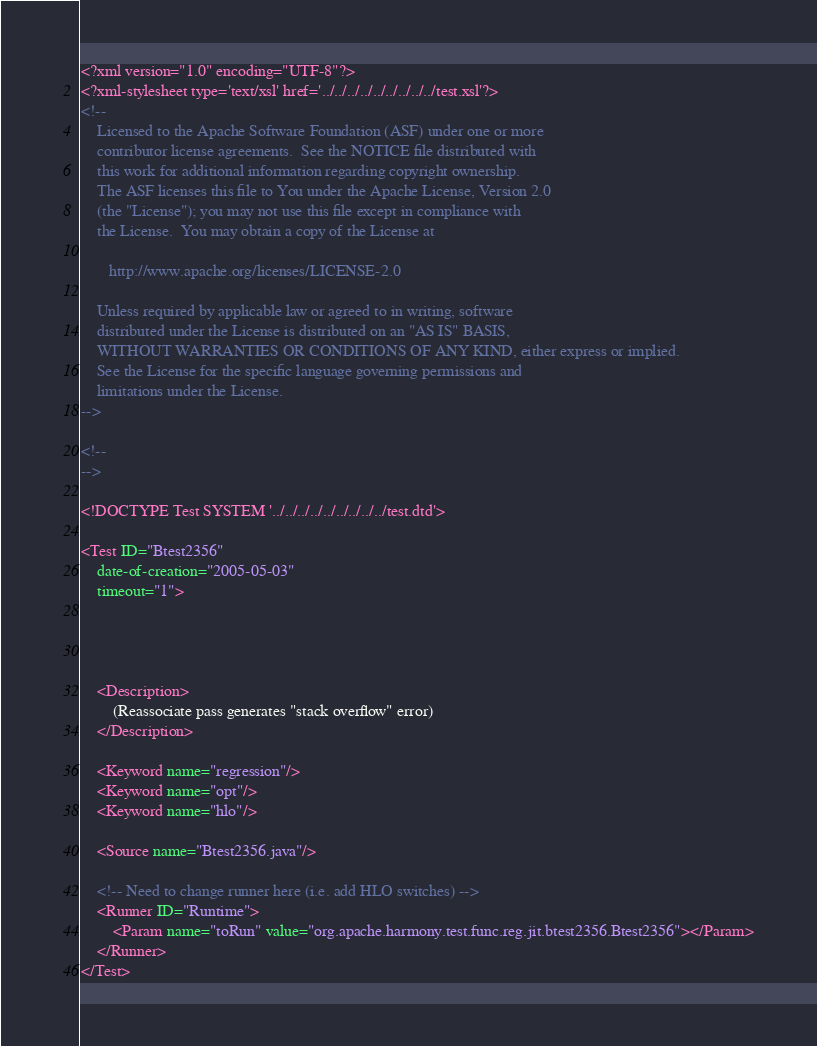<code> <loc_0><loc_0><loc_500><loc_500><_XML_><?xml version="1.0" encoding="UTF-8"?>
<?xml-stylesheet type='text/xsl' href='../../../../../../../../../test.xsl'?>
<!--
    Licensed to the Apache Software Foundation (ASF) under one or more
    contributor license agreements.  See the NOTICE file distributed with
    this work for additional information regarding copyright ownership.
    The ASF licenses this file to You under the Apache License, Version 2.0
    (the "License"); you may not use this file except in compliance with
    the License.  You may obtain a copy of the License at
  
       http://www.apache.org/licenses/LICENSE-2.0
  
    Unless required by applicable law or agreed to in writing, software
    distributed under the License is distributed on an "AS IS" BASIS,
    WITHOUT WARRANTIES OR CONDITIONS OF ANY KIND, either express or implied.
    See the License for the specific language governing permissions and
    limitations under the License.
-->

<!--
-->

<!DOCTYPE Test SYSTEM '../../../../../../../../../test.dtd'>

<Test ID="Btest2356"
    date-of-creation="2005-05-03"
    timeout="1">

    
    

    <Description>
        (Reassociate pass generates "stack overflow" error)
    </Description>

    <Keyword name="regression"/> 
    <Keyword name="opt"/> 
    <Keyword name="hlo"/> 

    <Source name="Btest2356.java"/>

    <!-- Need to change runner here (i.e. add HLO switches) -->
    <Runner ID="Runtime">
        <Param name="toRun" value="org.apache.harmony.test.func.reg.jit.btest2356.Btest2356"></Param>
    </Runner>
</Test> </code> 